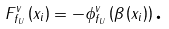<formula> <loc_0><loc_0><loc_500><loc_500>F _ { f _ { U } } ^ { v } \left ( x _ { i } \right ) = - \phi _ { f _ { U } } ^ { v } \left ( \beta \left ( x _ { i } \right ) \right ) \text {.}</formula> 